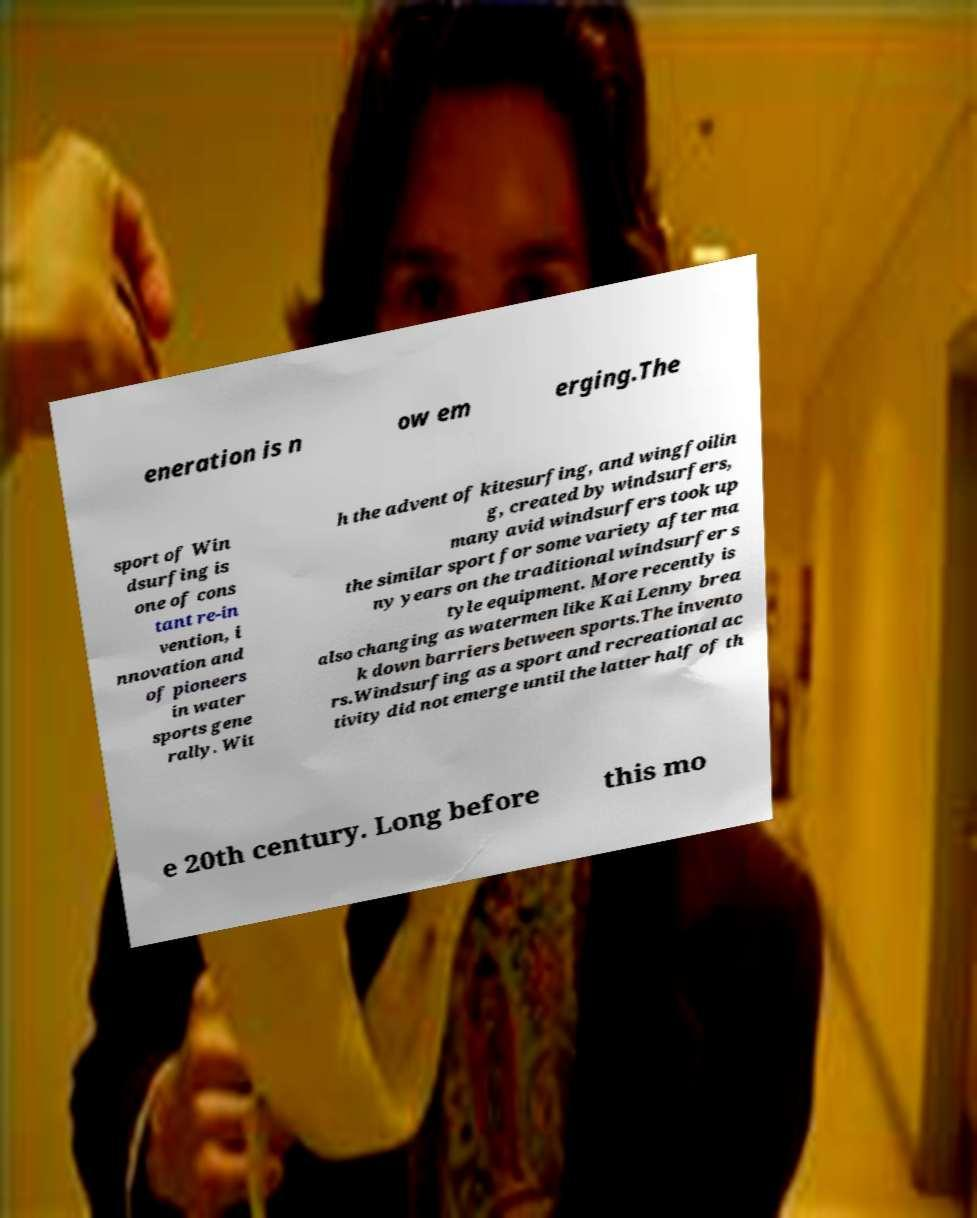Can you read and provide the text displayed in the image?This photo seems to have some interesting text. Can you extract and type it out for me? eneration is n ow em erging.The sport of Win dsurfing is one of cons tant re-in vention, i nnovation and of pioneers in water sports gene rally. Wit h the advent of kitesurfing, and wingfoilin g, created by windsurfers, many avid windsurfers took up the similar sport for some variety after ma ny years on the traditional windsurfer s tyle equipment. More recently is also changing as watermen like Kai Lenny brea k down barriers between sports.The invento rs.Windsurfing as a sport and recreational ac tivity did not emerge until the latter half of th e 20th century. Long before this mo 